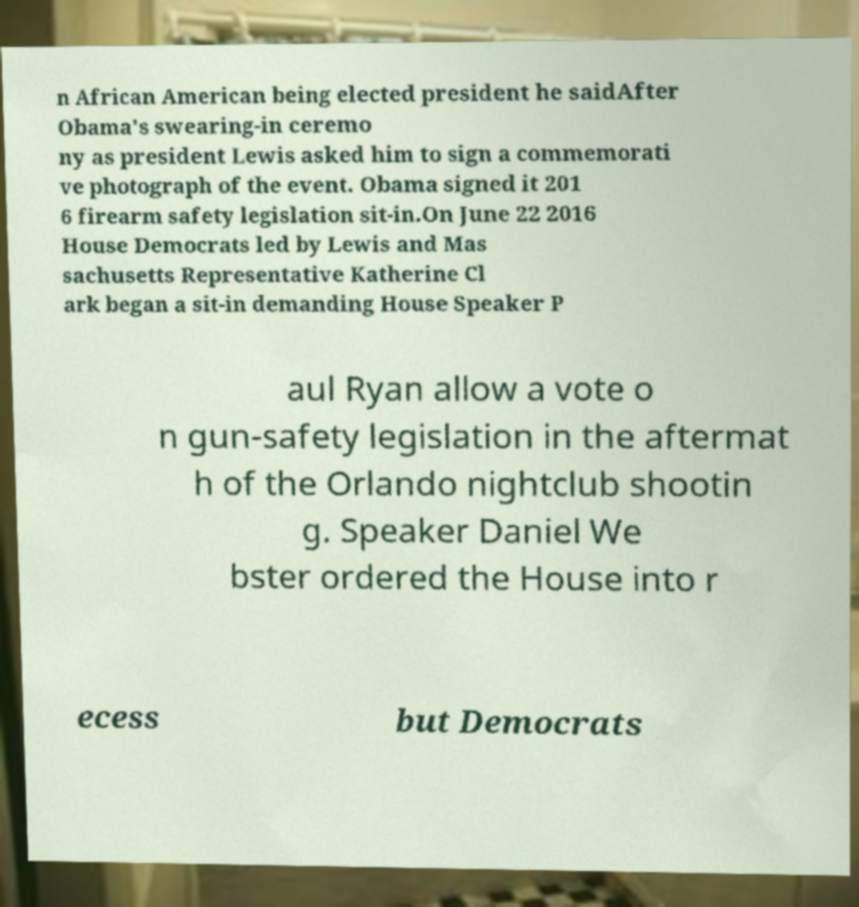What messages or text are displayed in this image? I need them in a readable, typed format. n African American being elected president he saidAfter Obama's swearing-in ceremo ny as president Lewis asked him to sign a commemorati ve photograph of the event. Obama signed it 201 6 firearm safety legislation sit-in.On June 22 2016 House Democrats led by Lewis and Mas sachusetts Representative Katherine Cl ark began a sit-in demanding House Speaker P aul Ryan allow a vote o n gun-safety legislation in the aftermat h of the Orlando nightclub shootin g. Speaker Daniel We bster ordered the House into r ecess but Democrats 